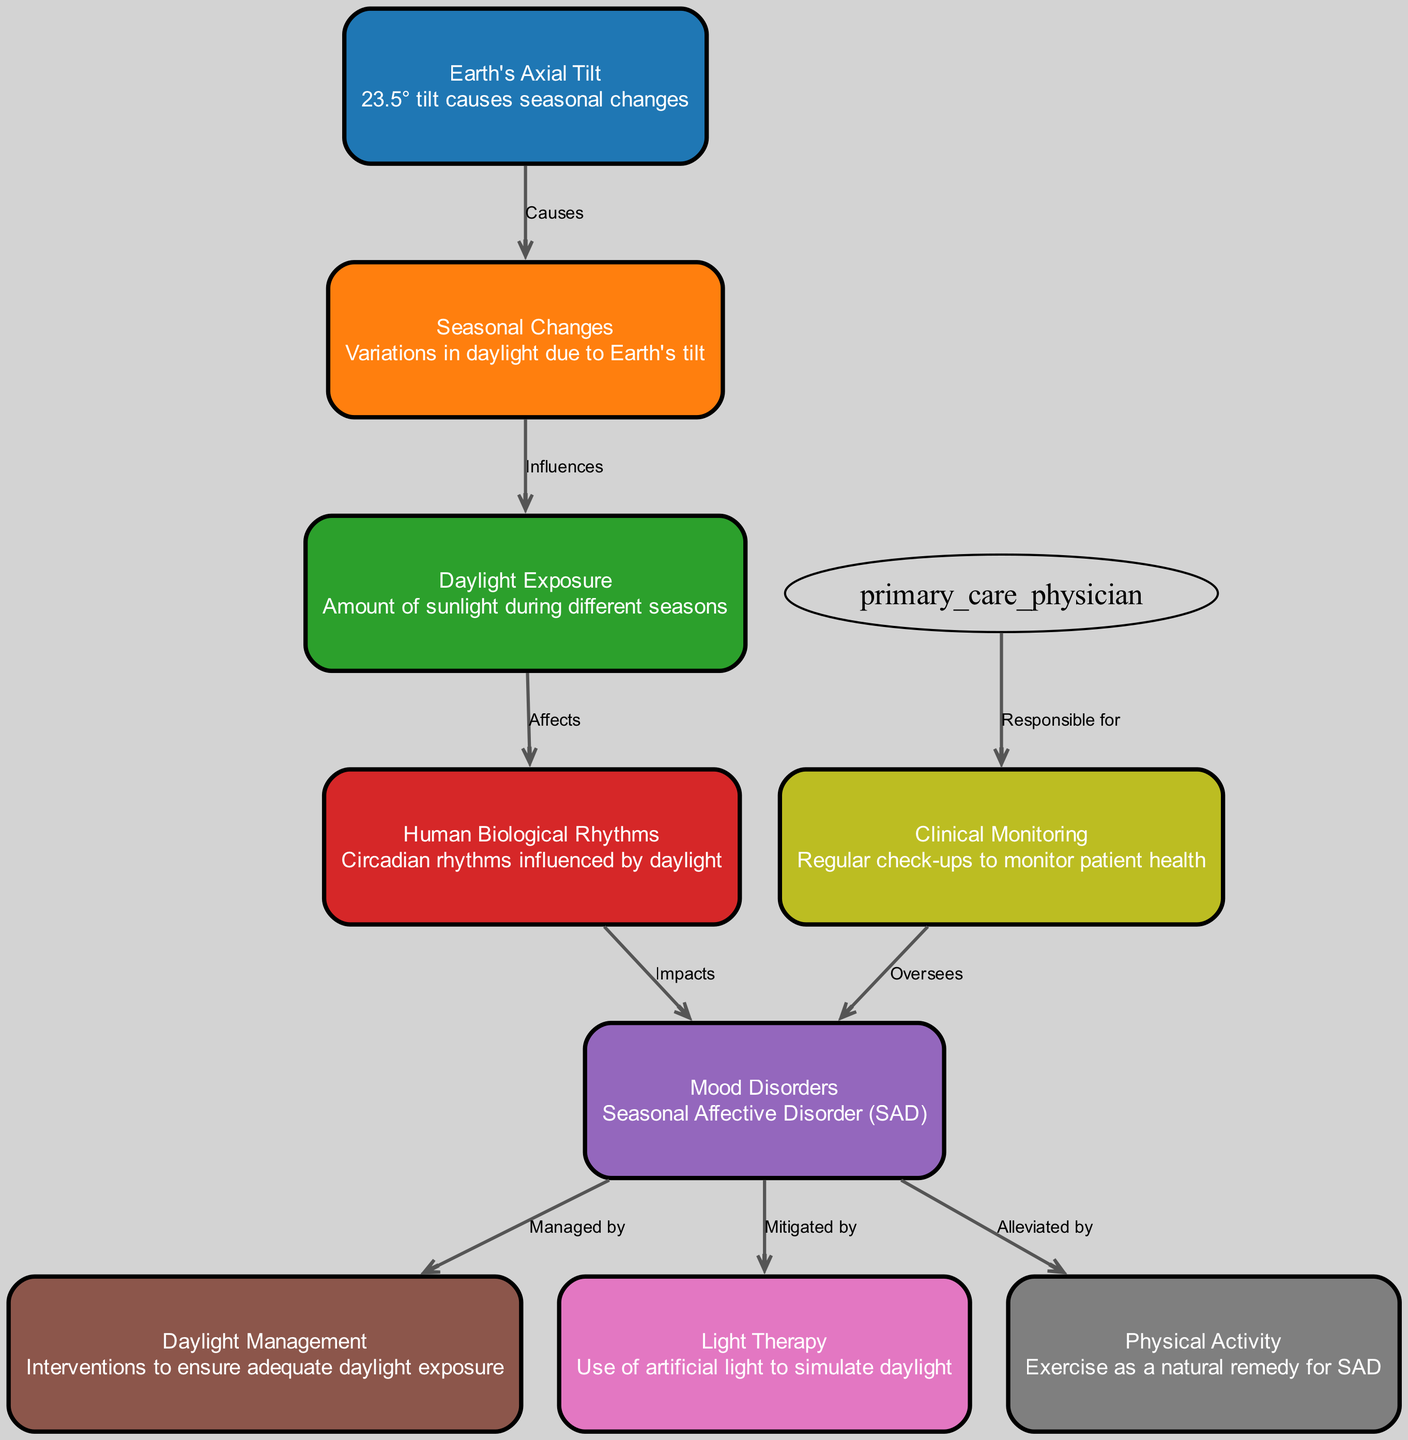What's the tilt angle of the Earth? The diagram states that Earth's axial tilt is 23.5 degrees, which is represented in the node labeled "Earth's Axial Tilt."
Answer: 23.5° What causes seasonal changes? The diagram indicates that seasonal changes are caused by the "Earth's Axial Tilt," as shown by the edge labeled "Causes."
Answer: Earth's Axial Tilt How many nodes are present in the diagram? By counting the nodes listed in the diagram data, there are 9 distinct nodes related to the influence of seasonal changes and human mood.
Answer: 9 What influences daylight exposure? The diagram specifies that daylight exposure is influenced by seasonal changes, as indicated in the edge between the nodes "Seasonal Changes" and "Daylight Exposure" labeled "Influences."
Answer: Seasonal Changes What kind of therapy is used to mitigate mood disorders? According to the diagram, "Light Therapy" is the treatment mentioned to mitigate mood disorders, specifically Seasonal Affective Disorder, as shown in the edge between "Mood Disorders" and "Light Therapy" labeled "Mitigated by."
Answer: Light Therapy How are human biological rhythms affected? The diagram notes that daylight exposure affects human biological rhythms, as per the connection between the nodes "Daylight Exposure" and "Human Biological Rhythms" labeled "Affects."
Answer: Daylight Exposure What role do primary care physicians have concerning mood disorders? The diagram illustrates that primary care physicians are responsible for "Clinical Monitoring," which oversees the health of patients with mood disorders. This relationship is depicted by the edge connecting these two nodes.
Answer: Clinical Monitoring What two interventions are shown to alleviate mood disorders? The diagram indicates that physical activity and light therapy are interventions that can alleviate mood disorders, referenced by the edges from "Mood Disorders" to both "Physical Activity" and "Light Therapy."
Answer: Physical Activity and Light Therapy How does clinical monitoring interact with mood disorders? The relationship shown in the diagram reveals that clinical monitoring oversees mood disorders, meaning it plays a direct role in the management and assessment of these conditions as indicated by the edge between the nodes.
Answer: Oversees 